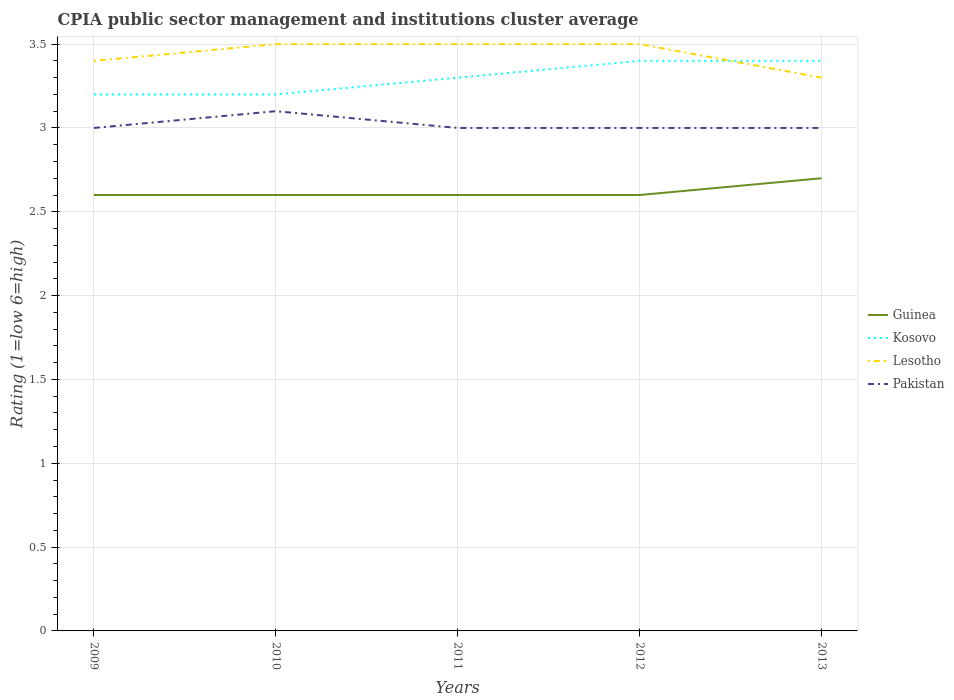How many different coloured lines are there?
Provide a short and direct response. 4. Does the line corresponding to Kosovo intersect with the line corresponding to Guinea?
Offer a terse response. No. In which year was the CPIA rating in Pakistan maximum?
Offer a terse response. 2009. What is the total CPIA rating in Pakistan in the graph?
Your response must be concise. 0.1. What is the difference between the highest and the second highest CPIA rating in Guinea?
Provide a succinct answer. 0.1. What is the difference between the highest and the lowest CPIA rating in Kosovo?
Give a very brief answer. 2. How many years are there in the graph?
Offer a terse response. 5. What is the difference between two consecutive major ticks on the Y-axis?
Make the answer very short. 0.5. Does the graph contain any zero values?
Make the answer very short. No. Does the graph contain grids?
Keep it short and to the point. Yes. Where does the legend appear in the graph?
Your answer should be compact. Center right. How many legend labels are there?
Give a very brief answer. 4. How are the legend labels stacked?
Your response must be concise. Vertical. What is the title of the graph?
Ensure brevity in your answer.  CPIA public sector management and institutions cluster average. Does "Sub-Saharan Africa (developing only)" appear as one of the legend labels in the graph?
Give a very brief answer. No. What is the label or title of the X-axis?
Ensure brevity in your answer.  Years. What is the label or title of the Y-axis?
Provide a succinct answer. Rating (1=low 6=high). What is the Rating (1=low 6=high) in Lesotho in 2009?
Give a very brief answer. 3.4. What is the Rating (1=low 6=high) of Pakistan in 2009?
Provide a succinct answer. 3. What is the Rating (1=low 6=high) in Guinea in 2010?
Offer a terse response. 2.6. What is the Rating (1=low 6=high) of Kosovo in 2010?
Your answer should be very brief. 3.2. What is the Rating (1=low 6=high) in Guinea in 2011?
Keep it short and to the point. 2.6. What is the Rating (1=low 6=high) of Guinea in 2012?
Provide a succinct answer. 2.6. What is the Rating (1=low 6=high) of Kosovo in 2012?
Offer a very short reply. 3.4. What is the Rating (1=low 6=high) of Pakistan in 2012?
Make the answer very short. 3. What is the Rating (1=low 6=high) in Guinea in 2013?
Make the answer very short. 2.7. What is the Rating (1=low 6=high) of Kosovo in 2013?
Your answer should be compact. 3.4. What is the Rating (1=low 6=high) in Pakistan in 2013?
Make the answer very short. 3. Across all years, what is the maximum Rating (1=low 6=high) of Guinea?
Ensure brevity in your answer.  2.7. Across all years, what is the maximum Rating (1=low 6=high) of Kosovo?
Offer a terse response. 3.4. Across all years, what is the minimum Rating (1=low 6=high) in Guinea?
Keep it short and to the point. 2.6. Across all years, what is the minimum Rating (1=low 6=high) of Kosovo?
Keep it short and to the point. 3.2. What is the total Rating (1=low 6=high) in Guinea in the graph?
Your answer should be compact. 13.1. What is the difference between the Rating (1=low 6=high) of Guinea in 2009 and that in 2010?
Your answer should be compact. 0. What is the difference between the Rating (1=low 6=high) in Lesotho in 2009 and that in 2010?
Your response must be concise. -0.1. What is the difference between the Rating (1=low 6=high) in Guinea in 2009 and that in 2011?
Make the answer very short. 0. What is the difference between the Rating (1=low 6=high) of Lesotho in 2009 and that in 2011?
Make the answer very short. -0.1. What is the difference between the Rating (1=low 6=high) of Pakistan in 2009 and that in 2011?
Your answer should be very brief. 0. What is the difference between the Rating (1=low 6=high) of Guinea in 2009 and that in 2012?
Provide a short and direct response. 0. What is the difference between the Rating (1=low 6=high) in Kosovo in 2009 and that in 2013?
Your answer should be compact. -0.2. What is the difference between the Rating (1=low 6=high) of Guinea in 2010 and that in 2011?
Keep it short and to the point. 0. What is the difference between the Rating (1=low 6=high) of Pakistan in 2010 and that in 2011?
Ensure brevity in your answer.  0.1. What is the difference between the Rating (1=low 6=high) in Lesotho in 2010 and that in 2012?
Keep it short and to the point. 0. What is the difference between the Rating (1=low 6=high) of Pakistan in 2010 and that in 2012?
Offer a very short reply. 0.1. What is the difference between the Rating (1=low 6=high) in Guinea in 2010 and that in 2013?
Ensure brevity in your answer.  -0.1. What is the difference between the Rating (1=low 6=high) in Pakistan in 2010 and that in 2013?
Offer a terse response. 0.1. What is the difference between the Rating (1=low 6=high) in Guinea in 2011 and that in 2012?
Keep it short and to the point. 0. What is the difference between the Rating (1=low 6=high) of Kosovo in 2011 and that in 2012?
Make the answer very short. -0.1. What is the difference between the Rating (1=low 6=high) of Pakistan in 2011 and that in 2012?
Ensure brevity in your answer.  0. What is the difference between the Rating (1=low 6=high) of Kosovo in 2011 and that in 2013?
Offer a very short reply. -0.1. What is the difference between the Rating (1=low 6=high) of Lesotho in 2011 and that in 2013?
Provide a short and direct response. 0.2. What is the difference between the Rating (1=low 6=high) of Guinea in 2012 and that in 2013?
Provide a succinct answer. -0.1. What is the difference between the Rating (1=low 6=high) of Kosovo in 2012 and that in 2013?
Your answer should be very brief. 0. What is the difference between the Rating (1=low 6=high) of Pakistan in 2012 and that in 2013?
Keep it short and to the point. 0. What is the difference between the Rating (1=low 6=high) of Guinea in 2009 and the Rating (1=low 6=high) of Lesotho in 2010?
Keep it short and to the point. -0.9. What is the difference between the Rating (1=low 6=high) in Kosovo in 2009 and the Rating (1=low 6=high) in Lesotho in 2010?
Keep it short and to the point. -0.3. What is the difference between the Rating (1=low 6=high) in Kosovo in 2009 and the Rating (1=low 6=high) in Pakistan in 2010?
Keep it short and to the point. 0.1. What is the difference between the Rating (1=low 6=high) of Guinea in 2009 and the Rating (1=low 6=high) of Kosovo in 2011?
Provide a succinct answer. -0.7. What is the difference between the Rating (1=low 6=high) of Guinea in 2009 and the Rating (1=low 6=high) of Pakistan in 2011?
Offer a very short reply. -0.4. What is the difference between the Rating (1=low 6=high) in Kosovo in 2009 and the Rating (1=low 6=high) in Pakistan in 2011?
Your answer should be compact. 0.2. What is the difference between the Rating (1=low 6=high) in Guinea in 2009 and the Rating (1=low 6=high) in Lesotho in 2012?
Offer a terse response. -0.9. What is the difference between the Rating (1=low 6=high) in Kosovo in 2009 and the Rating (1=low 6=high) in Lesotho in 2012?
Offer a terse response. -0.3. What is the difference between the Rating (1=low 6=high) in Guinea in 2009 and the Rating (1=low 6=high) in Kosovo in 2013?
Give a very brief answer. -0.8. What is the difference between the Rating (1=low 6=high) of Guinea in 2009 and the Rating (1=low 6=high) of Lesotho in 2013?
Ensure brevity in your answer.  -0.7. What is the difference between the Rating (1=low 6=high) of Guinea in 2009 and the Rating (1=low 6=high) of Pakistan in 2013?
Offer a terse response. -0.4. What is the difference between the Rating (1=low 6=high) of Kosovo in 2009 and the Rating (1=low 6=high) of Lesotho in 2013?
Offer a very short reply. -0.1. What is the difference between the Rating (1=low 6=high) of Guinea in 2010 and the Rating (1=low 6=high) of Pakistan in 2011?
Your response must be concise. -0.4. What is the difference between the Rating (1=low 6=high) in Kosovo in 2010 and the Rating (1=low 6=high) in Lesotho in 2011?
Your answer should be compact. -0.3. What is the difference between the Rating (1=low 6=high) of Guinea in 2010 and the Rating (1=low 6=high) of Lesotho in 2012?
Your answer should be compact. -0.9. What is the difference between the Rating (1=low 6=high) of Kosovo in 2010 and the Rating (1=low 6=high) of Pakistan in 2012?
Provide a succinct answer. 0.2. What is the difference between the Rating (1=low 6=high) of Lesotho in 2010 and the Rating (1=low 6=high) of Pakistan in 2012?
Your response must be concise. 0.5. What is the difference between the Rating (1=low 6=high) in Guinea in 2010 and the Rating (1=low 6=high) in Kosovo in 2013?
Keep it short and to the point. -0.8. What is the difference between the Rating (1=low 6=high) in Kosovo in 2010 and the Rating (1=low 6=high) in Pakistan in 2013?
Offer a very short reply. 0.2. What is the difference between the Rating (1=low 6=high) in Lesotho in 2010 and the Rating (1=low 6=high) in Pakistan in 2013?
Your answer should be very brief. 0.5. What is the difference between the Rating (1=low 6=high) of Guinea in 2011 and the Rating (1=low 6=high) of Kosovo in 2012?
Offer a terse response. -0.8. What is the difference between the Rating (1=low 6=high) of Kosovo in 2011 and the Rating (1=low 6=high) of Lesotho in 2012?
Ensure brevity in your answer.  -0.2. What is the difference between the Rating (1=low 6=high) in Lesotho in 2011 and the Rating (1=low 6=high) in Pakistan in 2012?
Give a very brief answer. 0.5. What is the difference between the Rating (1=low 6=high) of Guinea in 2011 and the Rating (1=low 6=high) of Kosovo in 2013?
Provide a short and direct response. -0.8. What is the difference between the Rating (1=low 6=high) in Guinea in 2011 and the Rating (1=low 6=high) in Lesotho in 2013?
Offer a terse response. -0.7. What is the difference between the Rating (1=low 6=high) of Guinea in 2012 and the Rating (1=low 6=high) of Kosovo in 2013?
Offer a terse response. -0.8. What is the difference between the Rating (1=low 6=high) of Kosovo in 2012 and the Rating (1=low 6=high) of Lesotho in 2013?
Your response must be concise. 0.1. What is the difference between the Rating (1=low 6=high) in Kosovo in 2012 and the Rating (1=low 6=high) in Pakistan in 2013?
Provide a short and direct response. 0.4. What is the difference between the Rating (1=low 6=high) in Lesotho in 2012 and the Rating (1=low 6=high) in Pakistan in 2013?
Your response must be concise. 0.5. What is the average Rating (1=low 6=high) in Guinea per year?
Give a very brief answer. 2.62. What is the average Rating (1=low 6=high) in Kosovo per year?
Ensure brevity in your answer.  3.3. What is the average Rating (1=low 6=high) of Lesotho per year?
Your answer should be very brief. 3.44. What is the average Rating (1=low 6=high) in Pakistan per year?
Ensure brevity in your answer.  3.02. In the year 2009, what is the difference between the Rating (1=low 6=high) of Guinea and Rating (1=low 6=high) of Kosovo?
Provide a succinct answer. -0.6. In the year 2009, what is the difference between the Rating (1=low 6=high) of Kosovo and Rating (1=low 6=high) of Pakistan?
Provide a succinct answer. 0.2. In the year 2010, what is the difference between the Rating (1=low 6=high) of Guinea and Rating (1=low 6=high) of Kosovo?
Give a very brief answer. -0.6. In the year 2011, what is the difference between the Rating (1=low 6=high) of Guinea and Rating (1=low 6=high) of Kosovo?
Offer a terse response. -0.7. In the year 2011, what is the difference between the Rating (1=low 6=high) of Kosovo and Rating (1=low 6=high) of Pakistan?
Your response must be concise. 0.3. In the year 2011, what is the difference between the Rating (1=low 6=high) of Lesotho and Rating (1=low 6=high) of Pakistan?
Your response must be concise. 0.5. In the year 2012, what is the difference between the Rating (1=low 6=high) of Guinea and Rating (1=low 6=high) of Pakistan?
Your response must be concise. -0.4. In the year 2012, what is the difference between the Rating (1=low 6=high) in Kosovo and Rating (1=low 6=high) in Lesotho?
Ensure brevity in your answer.  -0.1. In the year 2012, what is the difference between the Rating (1=low 6=high) in Kosovo and Rating (1=low 6=high) in Pakistan?
Ensure brevity in your answer.  0.4. In the year 2012, what is the difference between the Rating (1=low 6=high) of Lesotho and Rating (1=low 6=high) of Pakistan?
Offer a terse response. 0.5. In the year 2013, what is the difference between the Rating (1=low 6=high) in Guinea and Rating (1=low 6=high) in Kosovo?
Offer a terse response. -0.7. In the year 2013, what is the difference between the Rating (1=low 6=high) in Guinea and Rating (1=low 6=high) in Lesotho?
Keep it short and to the point. -0.6. In the year 2013, what is the difference between the Rating (1=low 6=high) of Guinea and Rating (1=low 6=high) of Pakistan?
Provide a short and direct response. -0.3. In the year 2013, what is the difference between the Rating (1=low 6=high) in Lesotho and Rating (1=low 6=high) in Pakistan?
Provide a succinct answer. 0.3. What is the ratio of the Rating (1=low 6=high) of Guinea in 2009 to that in 2010?
Ensure brevity in your answer.  1. What is the ratio of the Rating (1=low 6=high) of Kosovo in 2009 to that in 2010?
Make the answer very short. 1. What is the ratio of the Rating (1=low 6=high) in Lesotho in 2009 to that in 2010?
Offer a terse response. 0.97. What is the ratio of the Rating (1=low 6=high) in Pakistan in 2009 to that in 2010?
Offer a terse response. 0.97. What is the ratio of the Rating (1=low 6=high) of Guinea in 2009 to that in 2011?
Offer a very short reply. 1. What is the ratio of the Rating (1=low 6=high) in Kosovo in 2009 to that in 2011?
Your answer should be very brief. 0.97. What is the ratio of the Rating (1=low 6=high) in Lesotho in 2009 to that in 2011?
Make the answer very short. 0.97. What is the ratio of the Rating (1=low 6=high) of Guinea in 2009 to that in 2012?
Make the answer very short. 1. What is the ratio of the Rating (1=low 6=high) of Kosovo in 2009 to that in 2012?
Give a very brief answer. 0.94. What is the ratio of the Rating (1=low 6=high) of Lesotho in 2009 to that in 2012?
Provide a succinct answer. 0.97. What is the ratio of the Rating (1=low 6=high) in Guinea in 2009 to that in 2013?
Your answer should be compact. 0.96. What is the ratio of the Rating (1=low 6=high) in Lesotho in 2009 to that in 2013?
Make the answer very short. 1.03. What is the ratio of the Rating (1=low 6=high) of Kosovo in 2010 to that in 2011?
Your answer should be compact. 0.97. What is the ratio of the Rating (1=low 6=high) of Lesotho in 2010 to that in 2011?
Your answer should be very brief. 1. What is the ratio of the Rating (1=low 6=high) of Pakistan in 2010 to that in 2011?
Provide a short and direct response. 1.03. What is the ratio of the Rating (1=low 6=high) of Guinea in 2010 to that in 2012?
Give a very brief answer. 1. What is the ratio of the Rating (1=low 6=high) in Kosovo in 2010 to that in 2012?
Offer a terse response. 0.94. What is the ratio of the Rating (1=low 6=high) of Guinea in 2010 to that in 2013?
Ensure brevity in your answer.  0.96. What is the ratio of the Rating (1=low 6=high) of Lesotho in 2010 to that in 2013?
Offer a very short reply. 1.06. What is the ratio of the Rating (1=low 6=high) in Pakistan in 2010 to that in 2013?
Give a very brief answer. 1.03. What is the ratio of the Rating (1=low 6=high) in Kosovo in 2011 to that in 2012?
Your answer should be compact. 0.97. What is the ratio of the Rating (1=low 6=high) of Guinea in 2011 to that in 2013?
Give a very brief answer. 0.96. What is the ratio of the Rating (1=low 6=high) in Kosovo in 2011 to that in 2013?
Keep it short and to the point. 0.97. What is the ratio of the Rating (1=low 6=high) of Lesotho in 2011 to that in 2013?
Offer a very short reply. 1.06. What is the ratio of the Rating (1=low 6=high) in Lesotho in 2012 to that in 2013?
Give a very brief answer. 1.06. What is the difference between the highest and the second highest Rating (1=low 6=high) of Guinea?
Your answer should be very brief. 0.1. What is the difference between the highest and the second highest Rating (1=low 6=high) of Kosovo?
Keep it short and to the point. 0. What is the difference between the highest and the second highest Rating (1=low 6=high) in Pakistan?
Your answer should be very brief. 0.1. What is the difference between the highest and the lowest Rating (1=low 6=high) in Kosovo?
Your answer should be compact. 0.2. What is the difference between the highest and the lowest Rating (1=low 6=high) in Lesotho?
Your answer should be very brief. 0.2. What is the difference between the highest and the lowest Rating (1=low 6=high) of Pakistan?
Your answer should be compact. 0.1. 